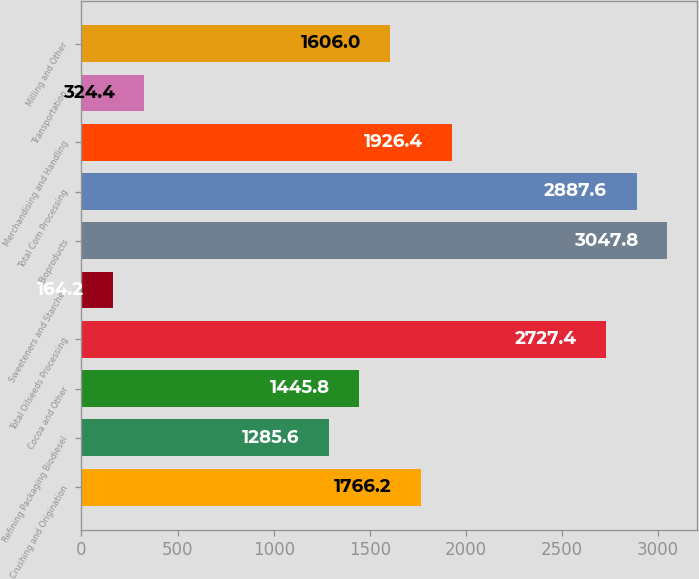Convert chart to OTSL. <chart><loc_0><loc_0><loc_500><loc_500><bar_chart><fcel>Crushing and Origination<fcel>Refining Packaging Biodiesel<fcel>Cocoa and Other<fcel>Total Oilseeds Processing<fcel>Sweeteners and Starches<fcel>Bioproducts<fcel>Total Corn Processing<fcel>Merchandising and Handling<fcel>Transportation<fcel>Milling and Other<nl><fcel>1766.2<fcel>1285.6<fcel>1445.8<fcel>2727.4<fcel>164.2<fcel>3047.8<fcel>2887.6<fcel>1926.4<fcel>324.4<fcel>1606<nl></chart> 